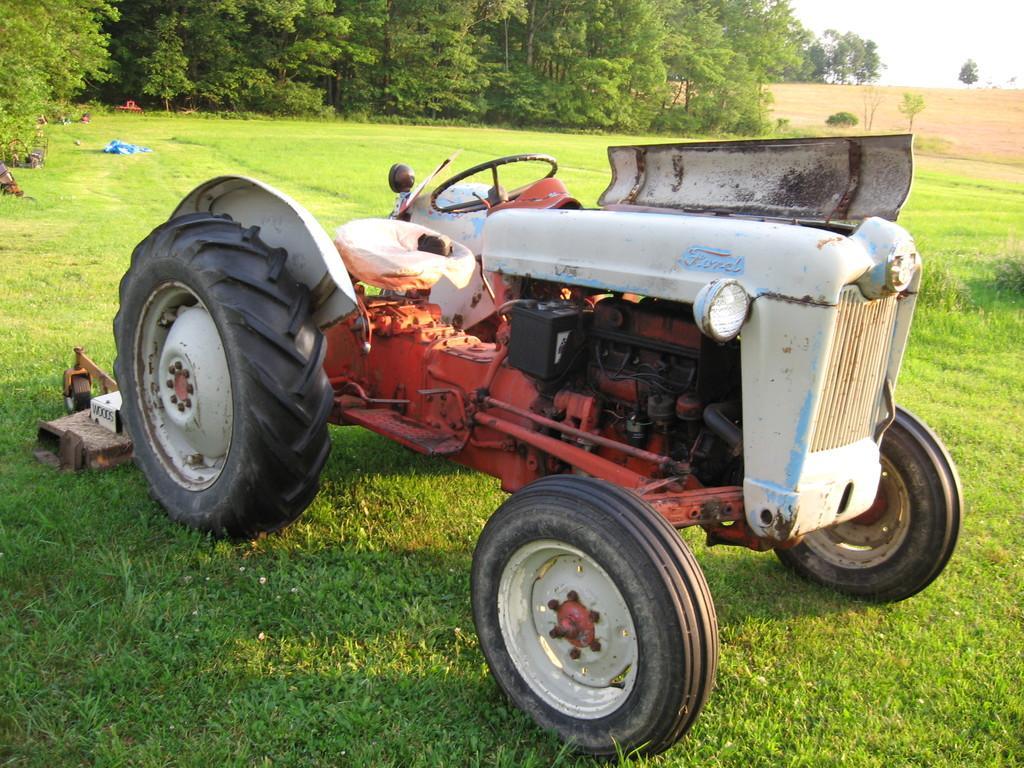Please provide a concise description of this image. In this picture I can see a tractor. In the background I can see trees, grass and the sky. Here I can see some objects on the grass. 